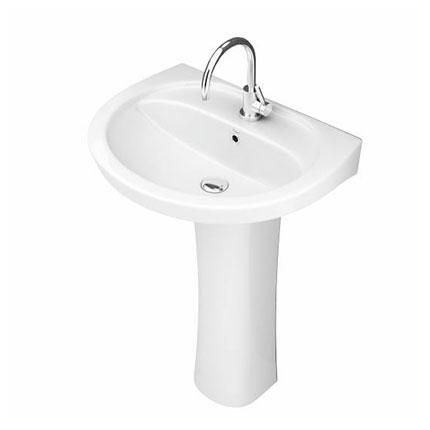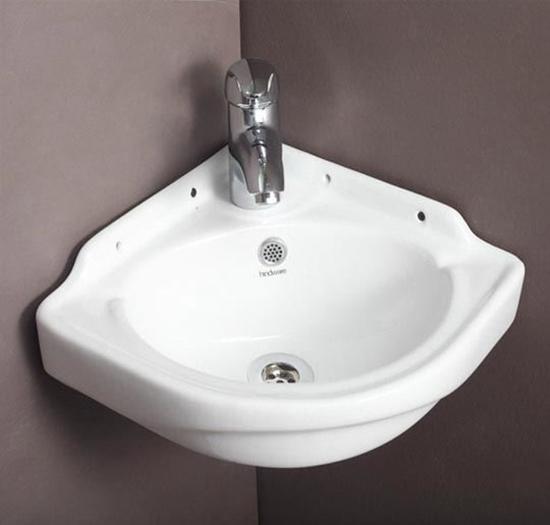The first image is the image on the left, the second image is the image on the right. Evaluate the accuracy of this statement regarding the images: "The drain hole is visible in only one image.". Is it true? Answer yes or no. No. 